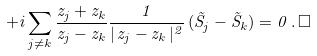<formula> <loc_0><loc_0><loc_500><loc_500>+ i \sum _ { j \neq k } \frac { z _ { j } + z _ { k } } { z _ { j } - z _ { k } } \frac { 1 } { | \, z _ { j } - z _ { k } \, | ^ { 2 } } \, ( \vec { S } _ { j } - \vec { S } _ { k } ) = 0 \, . \, \Box</formula> 